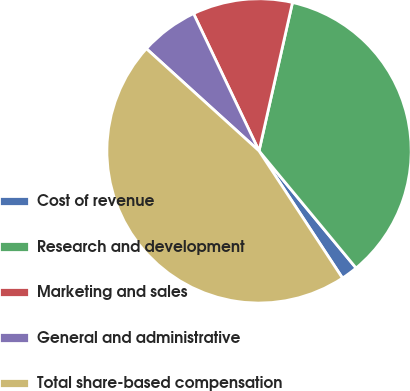<chart> <loc_0><loc_0><loc_500><loc_500><pie_chart><fcel>Cost of revenue<fcel>Research and development<fcel>Marketing and sales<fcel>General and administrative<fcel>Total share-based compensation<nl><fcel>1.77%<fcel>35.46%<fcel>10.61%<fcel>6.19%<fcel>45.97%<nl></chart> 